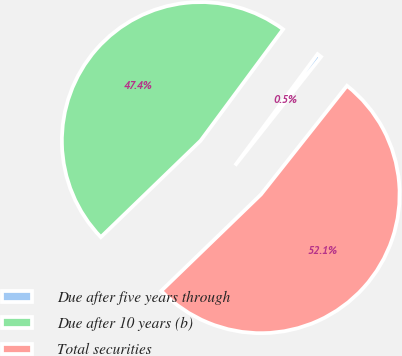Convert chart to OTSL. <chart><loc_0><loc_0><loc_500><loc_500><pie_chart><fcel>Due after five years through<fcel>Due after 10 years (b)<fcel>Total securities<nl><fcel>0.51%<fcel>47.37%<fcel>52.11%<nl></chart> 